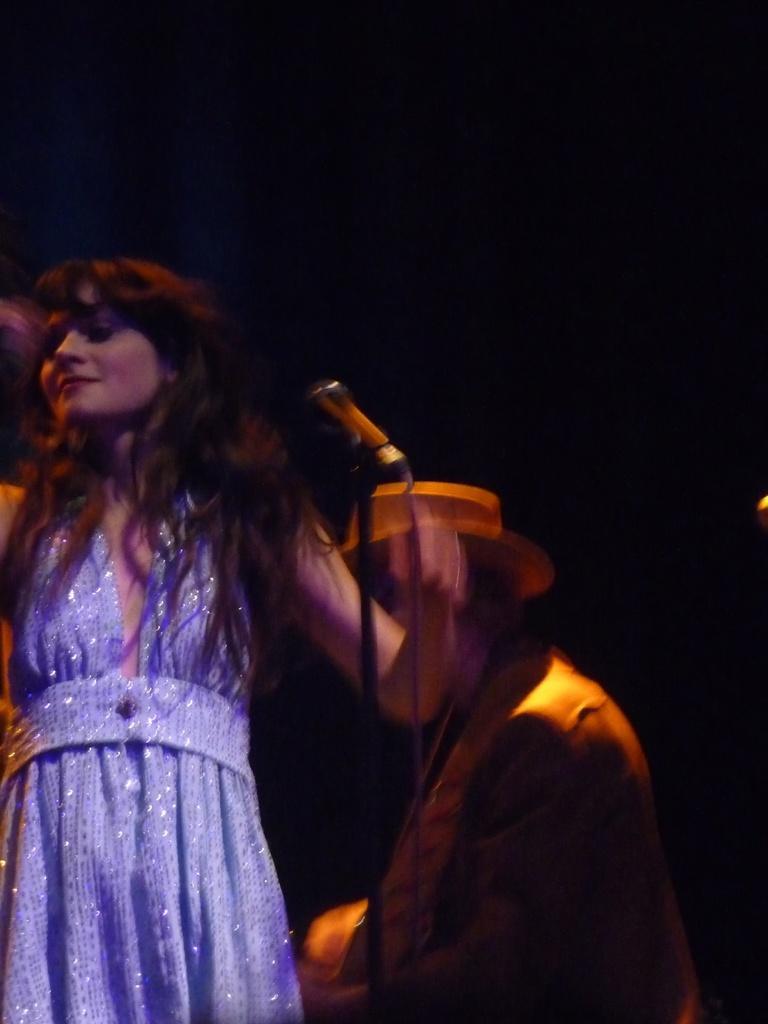Describe this image in one or two sentences. In this picture a woman in the purple dress is standing and in front of the woman there is a microphone with stand. Behind the woman there is a man and there is a dark background. 